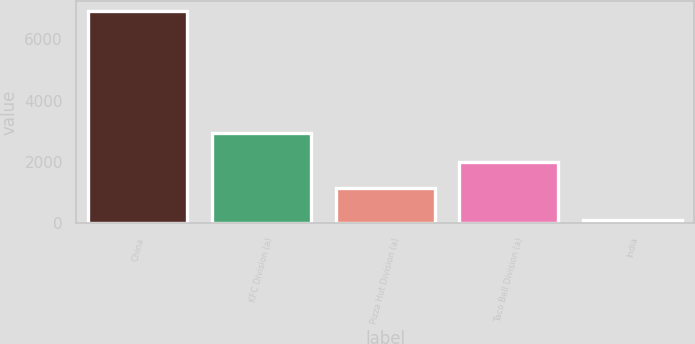Convert chart to OTSL. <chart><loc_0><loc_0><loc_500><loc_500><bar_chart><fcel>China<fcel>KFC Division (a)<fcel>Pizza Hut Division (a)<fcel>Taco Bell Division (a)<fcel>India<nl><fcel>6909<fcel>2948<fcel>1145<fcel>1988<fcel>115<nl></chart> 